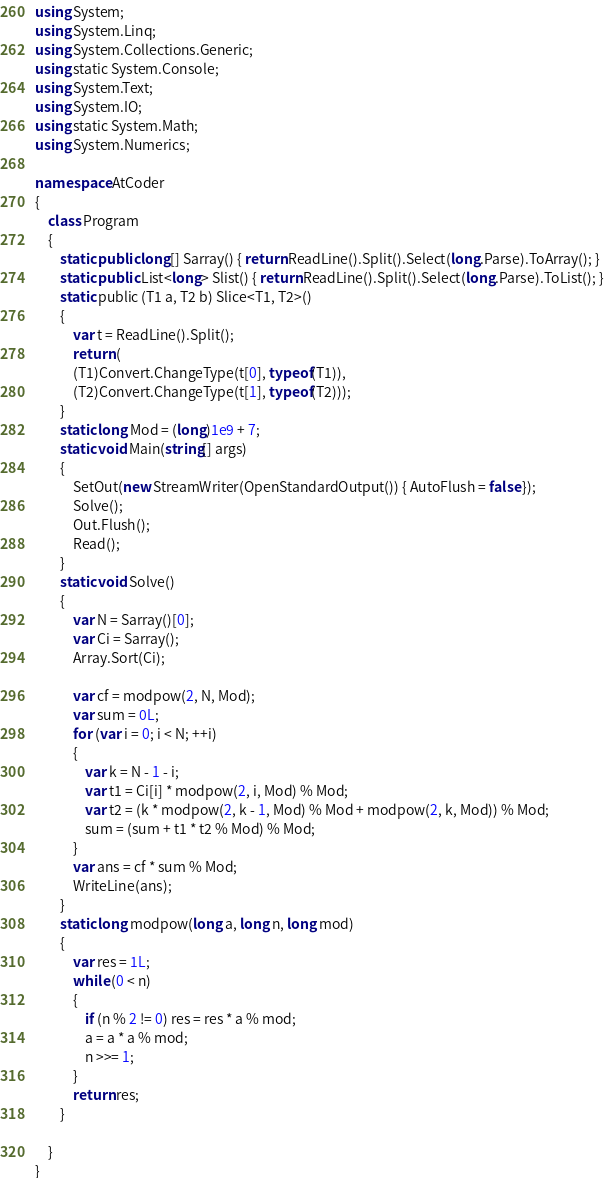Convert code to text. <code><loc_0><loc_0><loc_500><loc_500><_C#_>using System;
using System.Linq;
using System.Collections.Generic;
using static System.Console;
using System.Text;
using System.IO;
using static System.Math;
using System.Numerics;

namespace AtCoder
{
    class Program
    {
        static public long[] Sarray() { return ReadLine().Split().Select(long.Parse).ToArray(); }
        static public List<long> Slist() { return ReadLine().Split().Select(long.Parse).ToList(); }
        static public (T1 a, T2 b) Slice<T1, T2>()
        {
            var t = ReadLine().Split();
            return (
            (T1)Convert.ChangeType(t[0], typeof(T1)),
            (T2)Convert.ChangeType(t[1], typeof(T2)));
        }
        static long Mod = (long)1e9 + 7;
        static void Main(string[] args)
        {
            SetOut(new StreamWriter(OpenStandardOutput()) { AutoFlush = false });
            Solve();
            Out.Flush();
            Read();
        }
        static void Solve()
        {
            var N = Sarray()[0];
            var Ci = Sarray();
            Array.Sort(Ci);

            var cf = modpow(2, N, Mod);
            var sum = 0L;
            for (var i = 0; i < N; ++i)
            {
                var k = N - 1 - i;
                var t1 = Ci[i] * modpow(2, i, Mod) % Mod;
                var t2 = (k * modpow(2, k - 1, Mod) % Mod + modpow(2, k, Mod)) % Mod;
                sum = (sum + t1 * t2 % Mod) % Mod;
            }
            var ans = cf * sum % Mod;
            WriteLine(ans);
        }
        static long modpow(long a, long n, long mod)
        {
            var res = 1L;
            while (0 < n)
            {
                if (n % 2 != 0) res = res * a % mod;
                a = a * a % mod;
                n >>= 1;
            }
            return res;
        }

    }
}</code> 